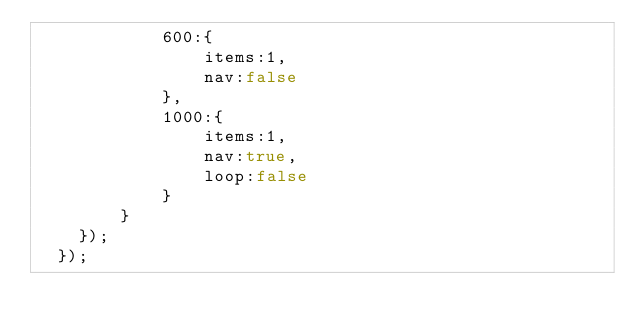<code> <loc_0><loc_0><loc_500><loc_500><_JavaScript_>            600:{
                items:1,
                nav:false
            },
            1000:{
                items:1,
                nav:true,
                loop:false
            }
        }
    });
  });</code> 